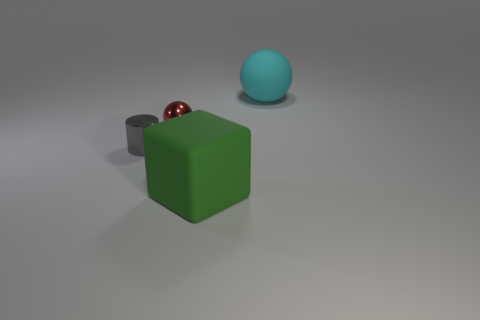Add 3 tiny red cubes. How many objects exist? 7 Subtract all red spheres. How many spheres are left? 1 Subtract all cylinders. How many objects are left? 3 Subtract 0 red cubes. How many objects are left? 4 Subtract 1 blocks. How many blocks are left? 0 Subtract all cyan spheres. Subtract all brown blocks. How many spheres are left? 1 Subtract all metal cylinders. Subtract all green matte things. How many objects are left? 2 Add 1 green things. How many green things are left? 2 Add 4 purple shiny spheres. How many purple shiny spheres exist? 4 